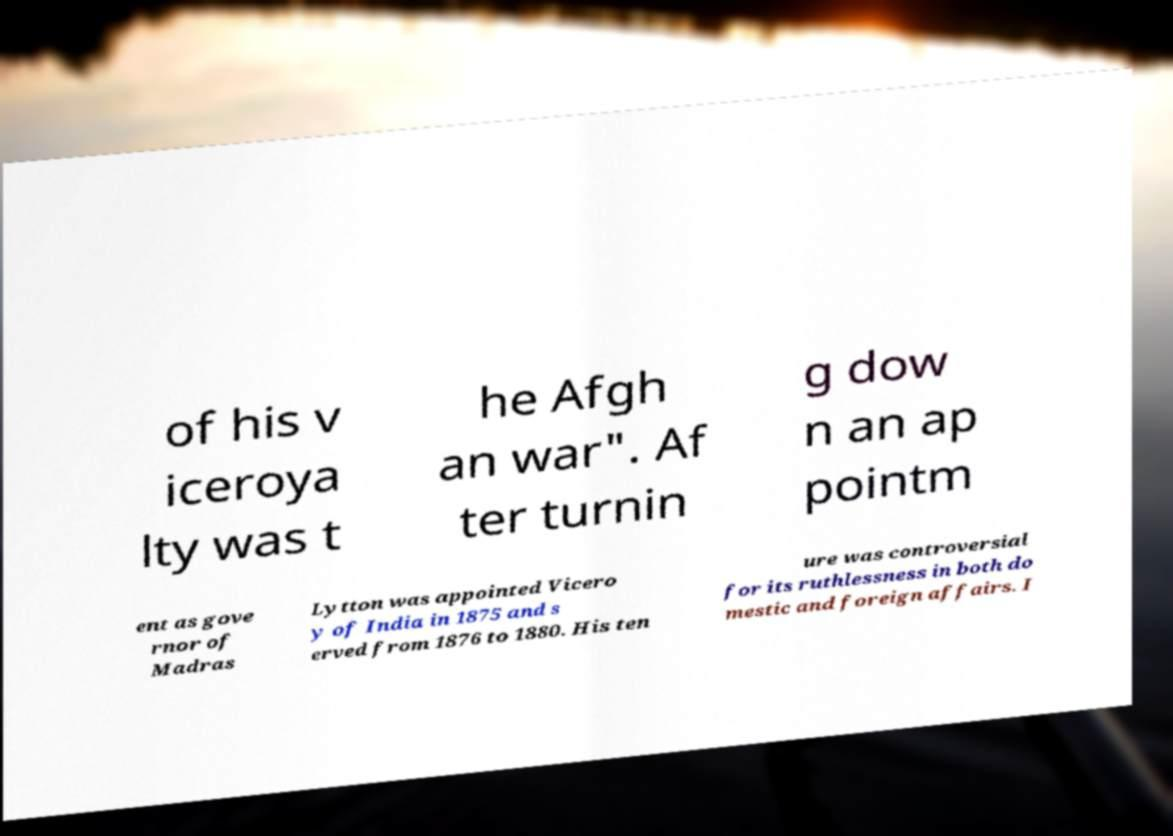Could you extract and type out the text from this image? of his v iceroya lty was t he Afgh an war". Af ter turnin g dow n an ap pointm ent as gove rnor of Madras Lytton was appointed Vicero y of India in 1875 and s erved from 1876 to 1880. His ten ure was controversial for its ruthlessness in both do mestic and foreign affairs. I 